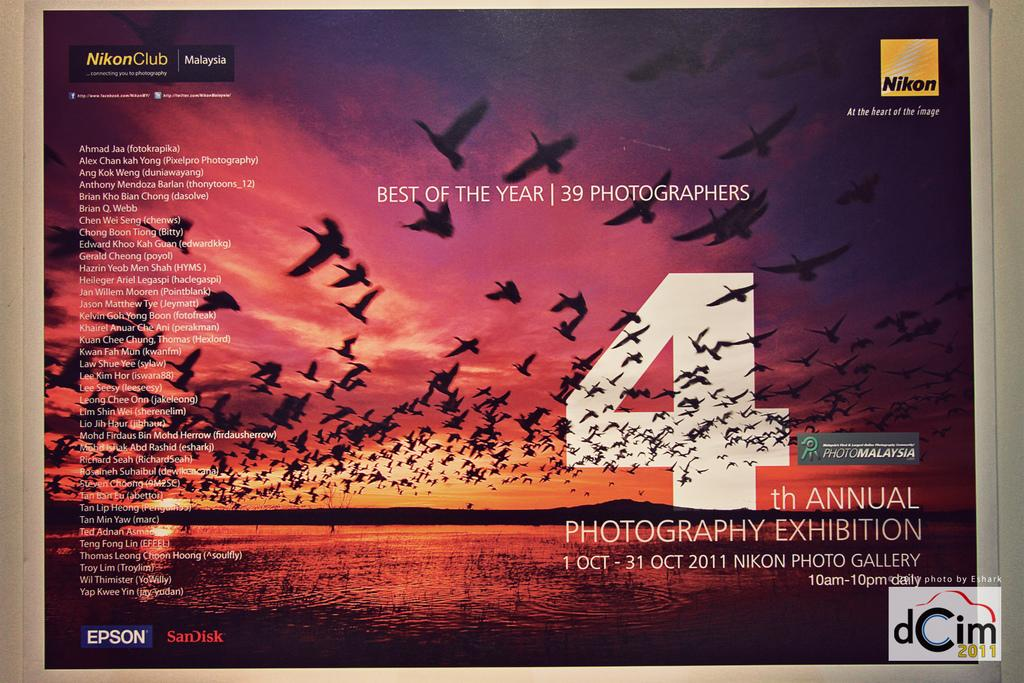<image>
Render a clear and concise summary of the photo. a poster with the number 4 on it on a wall 